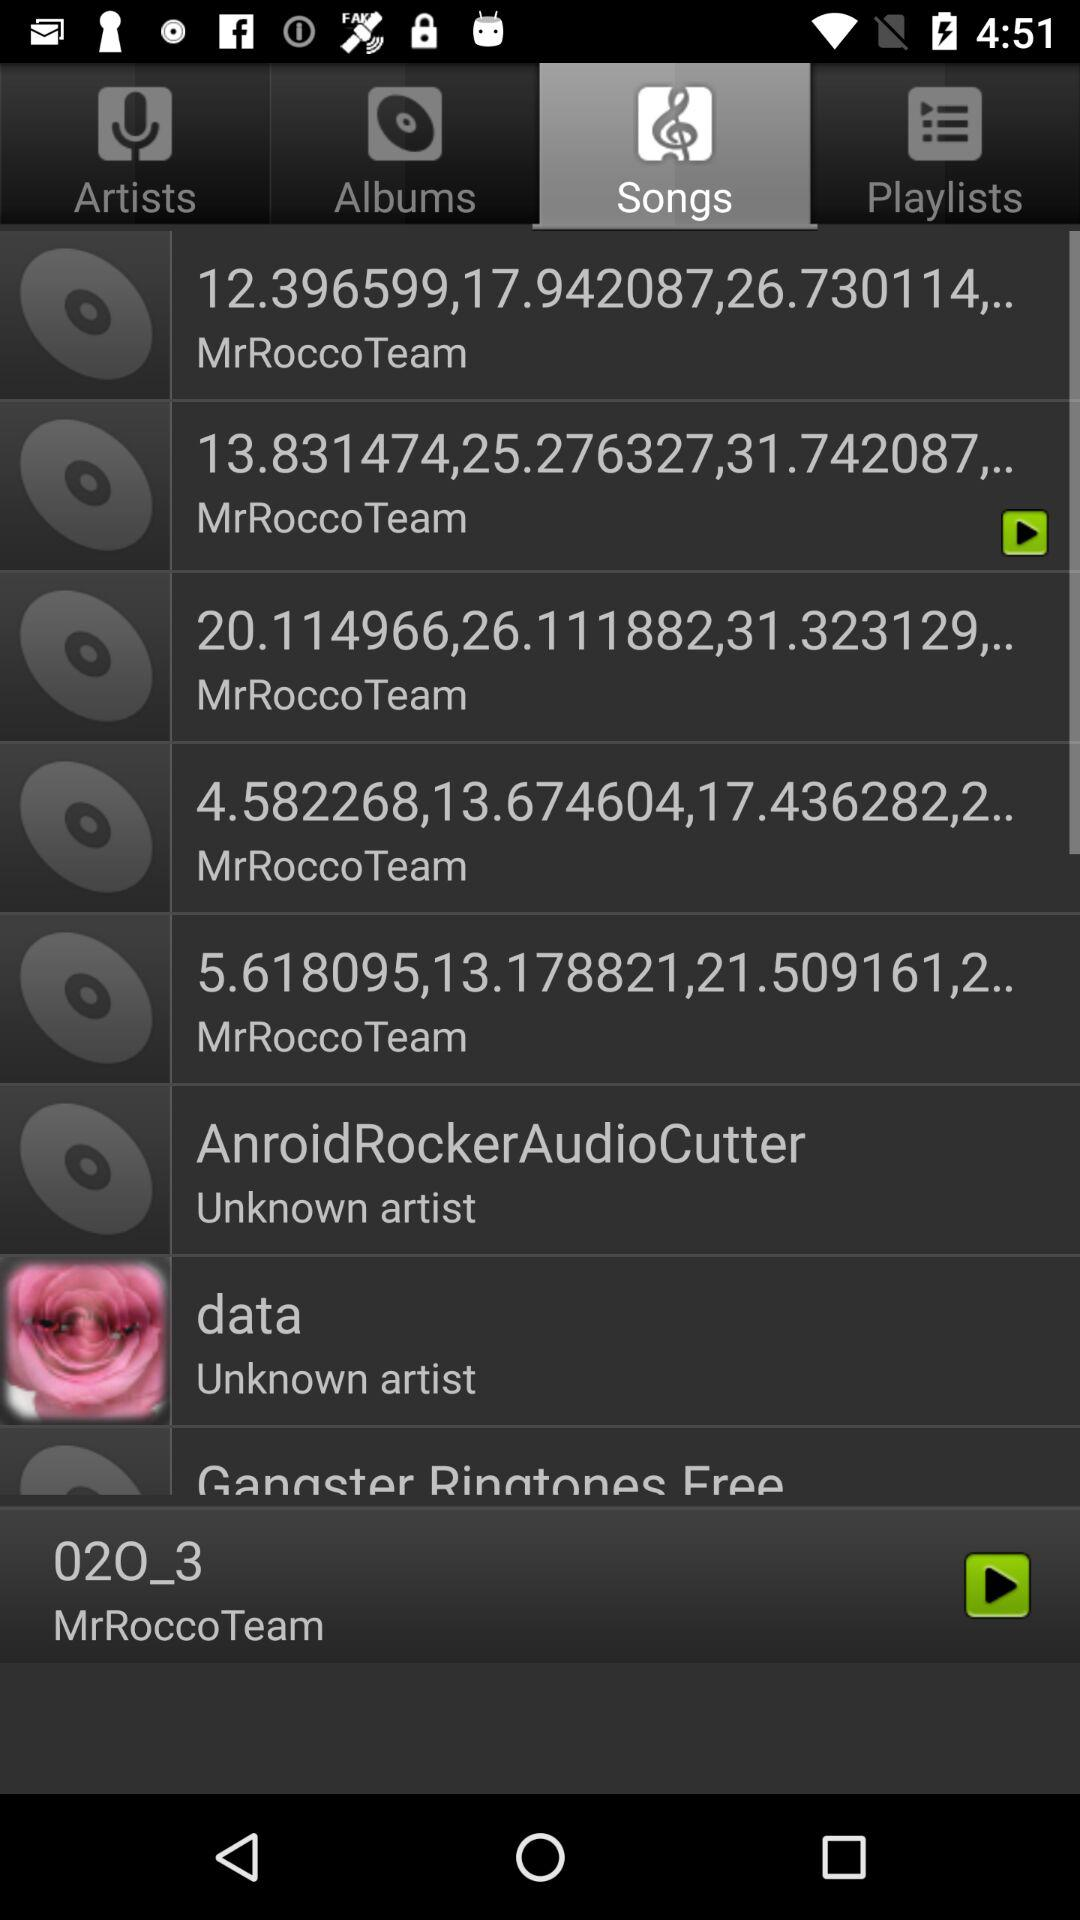Which song was last played? The last played song was "02O_3". 